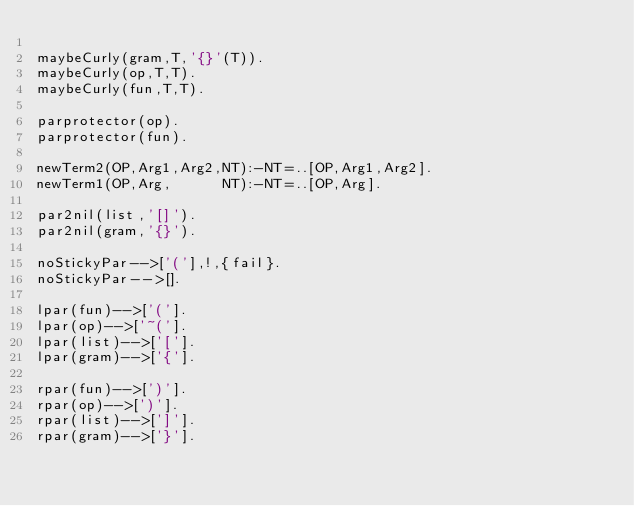Convert code to text. <code><loc_0><loc_0><loc_500><loc_500><_Perl_>
maybeCurly(gram,T,'{}'(T)).
maybeCurly(op,T,T).
maybeCurly(fun,T,T).

parprotector(op).
parprotector(fun).

newTerm2(OP,Arg1,Arg2,NT):-NT=..[OP,Arg1,Arg2].
newTerm1(OP,Arg,      NT):-NT=..[OP,Arg].

par2nil(list,'[]').
par2nil(gram,'{}').

noStickyPar-->['('],!,{fail}.
noStickyPar-->[].

lpar(fun)-->['('].
lpar(op)-->['~('].
lpar(list)-->['['].
lpar(gram)-->['{'].

rpar(fun)-->[')'].
rpar(op)-->[')'].
rpar(list)-->[']'].
rpar(gram)-->['}'].

</code> 